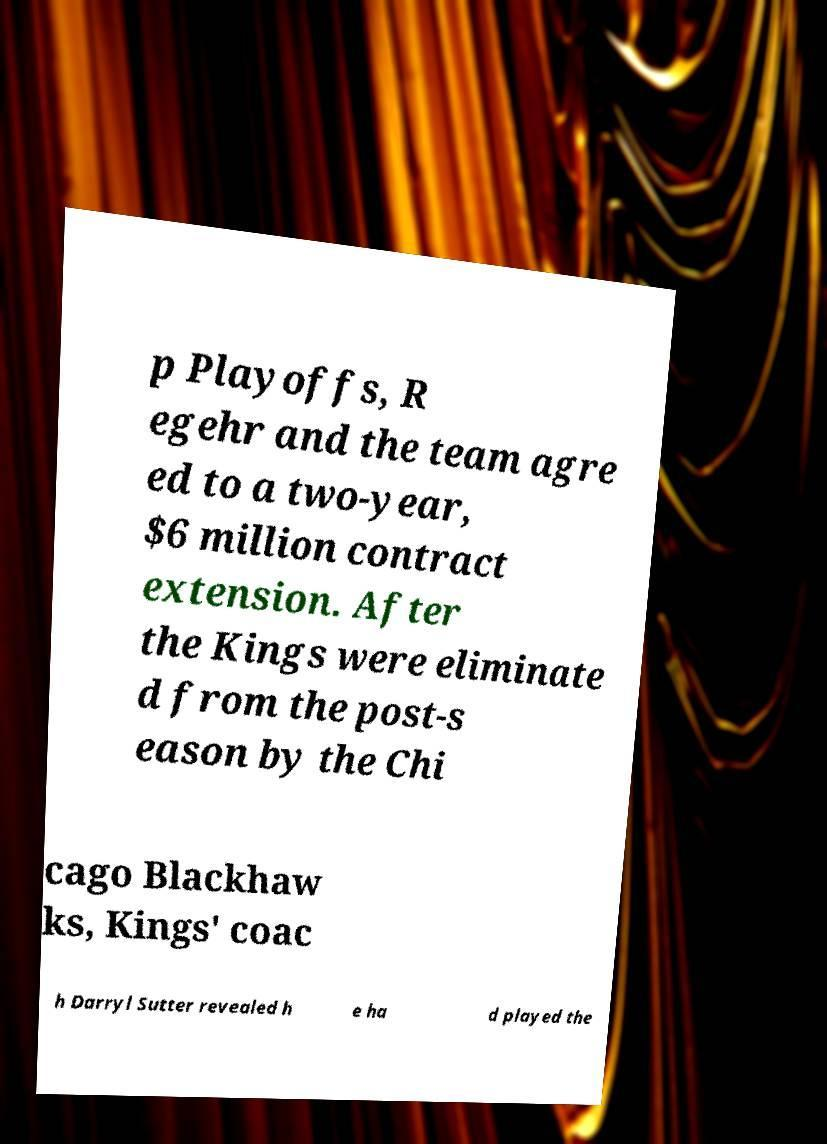Can you accurately transcribe the text from the provided image for me? p Playoffs, R egehr and the team agre ed to a two-year, $6 million contract extension. After the Kings were eliminate d from the post-s eason by the Chi cago Blackhaw ks, Kings' coac h Darryl Sutter revealed h e ha d played the 